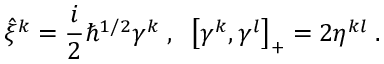Convert formula to latex. <formula><loc_0><loc_0><loc_500><loc_500>\hat { \xi } ^ { k } = \frac { i } { 2 } \hbar { ^ } { 1 / 2 } \gamma ^ { k } \, , \, \left [ \gamma ^ { k } , \gamma ^ { l } \right ] _ { + } = 2 \eta ^ { k l } \, .</formula> 